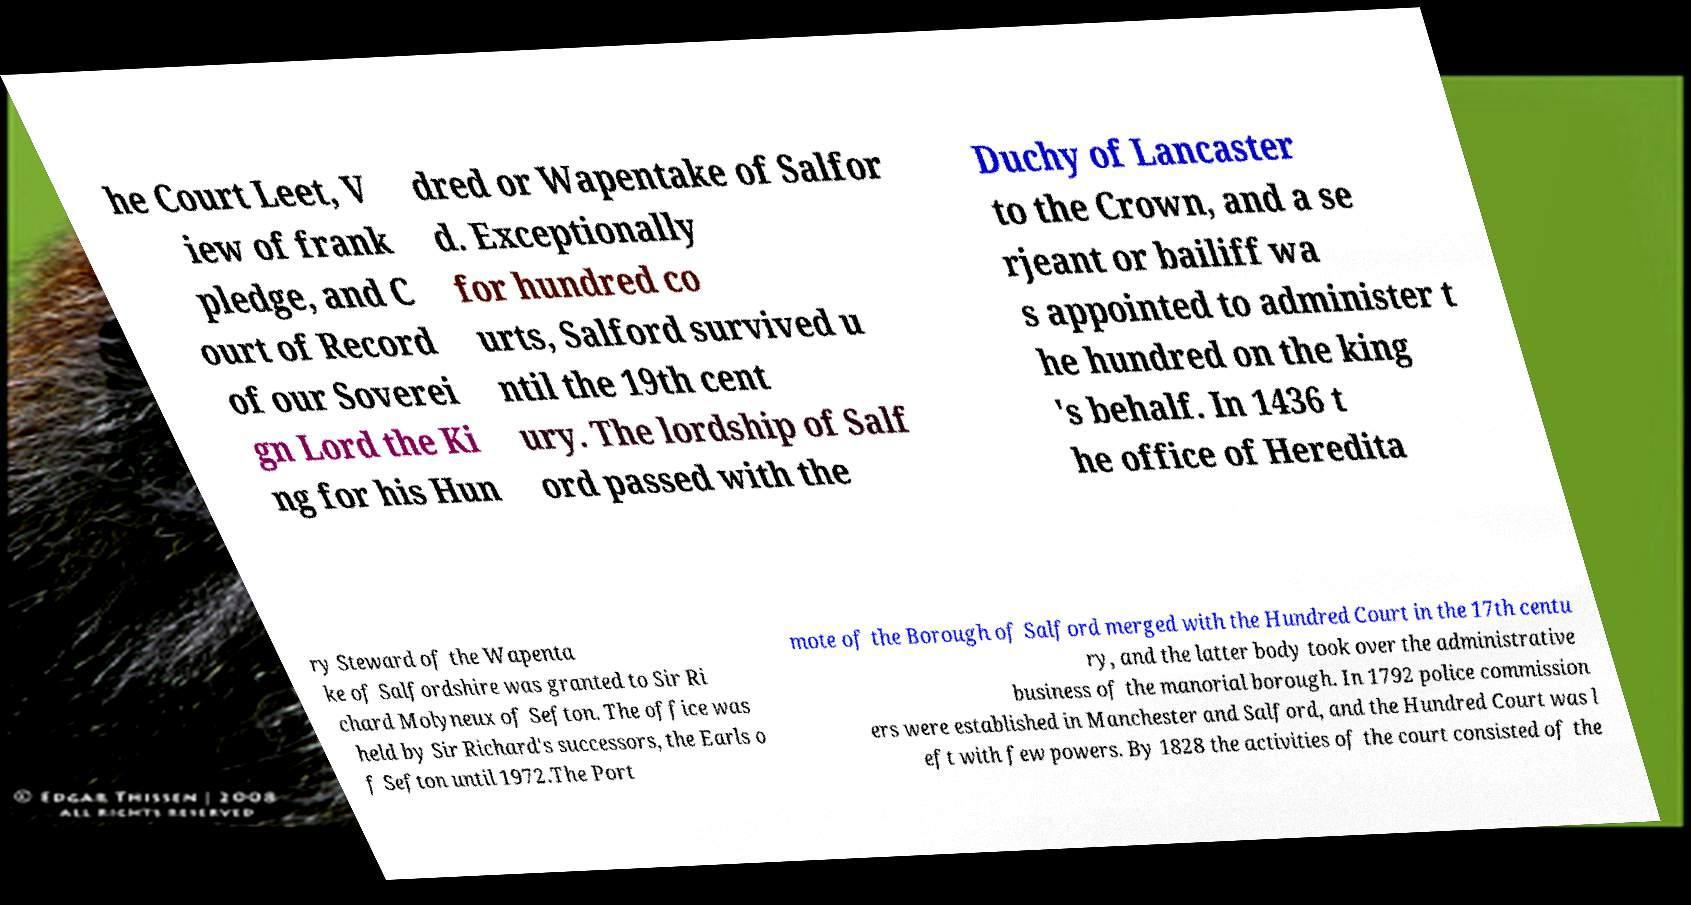Could you extract and type out the text from this image? he Court Leet, V iew of frank pledge, and C ourt of Record of our Soverei gn Lord the Ki ng for his Hun dred or Wapentake of Salfor d. Exceptionally for hundred co urts, Salford survived u ntil the 19th cent ury. The lordship of Salf ord passed with the Duchy of Lancaster to the Crown, and a se rjeant or bailiff wa s appointed to administer t he hundred on the king 's behalf. In 1436 t he office of Heredita ry Steward of the Wapenta ke of Salfordshire was granted to Sir Ri chard Molyneux of Sefton. The office was held by Sir Richard's successors, the Earls o f Sefton until 1972.The Port mote of the Borough of Salford merged with the Hundred Court in the 17th centu ry, and the latter body took over the administrative business of the manorial borough. In 1792 police commission ers were established in Manchester and Salford, and the Hundred Court was l eft with few powers. By 1828 the activities of the court consisted of the 